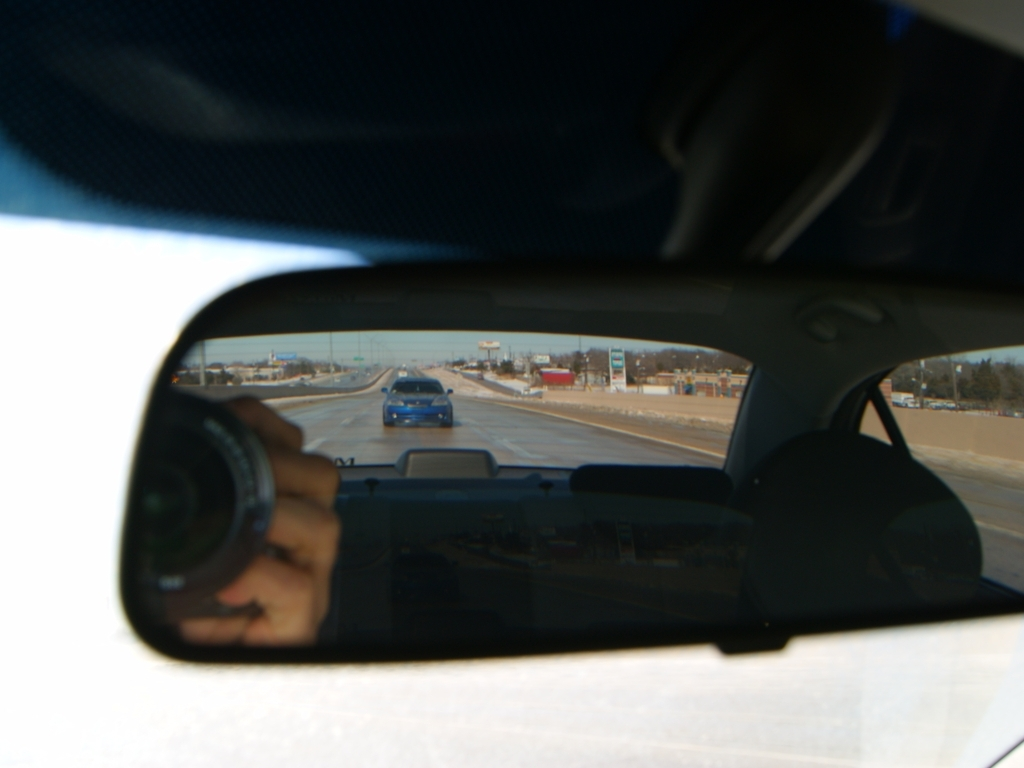Examine the image's quality and provide an evaluation based on your observations.
 This photo has a relatively high resolution. The main content of the image is the reflection on the car's rearview mirror, so there is a slight distortion. The colors in the image are rich. The scenery outside the car's front windshield is slightly overexposed. Therefore, the quality of this photo is considered average. 